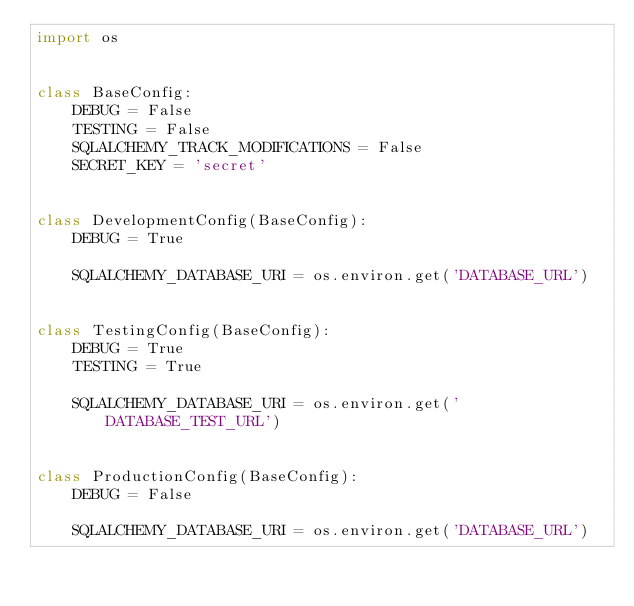<code> <loc_0><loc_0><loc_500><loc_500><_Python_>import os


class BaseConfig:
    DEBUG = False
    TESTING = False
    SQLALCHEMY_TRACK_MODIFICATIONS = False
    SECRET_KEY = 'secret'


class DevelopmentConfig(BaseConfig):
    DEBUG = True

    SQLALCHEMY_DATABASE_URI = os.environ.get('DATABASE_URL')


class TestingConfig(BaseConfig):
    DEBUG = True
    TESTING = True

    SQLALCHEMY_DATABASE_URI = os.environ.get('DATABASE_TEST_URL')


class ProductionConfig(BaseConfig):
    DEBUG = False

    SQLALCHEMY_DATABASE_URI = os.environ.get('DATABASE_URL')
</code> 